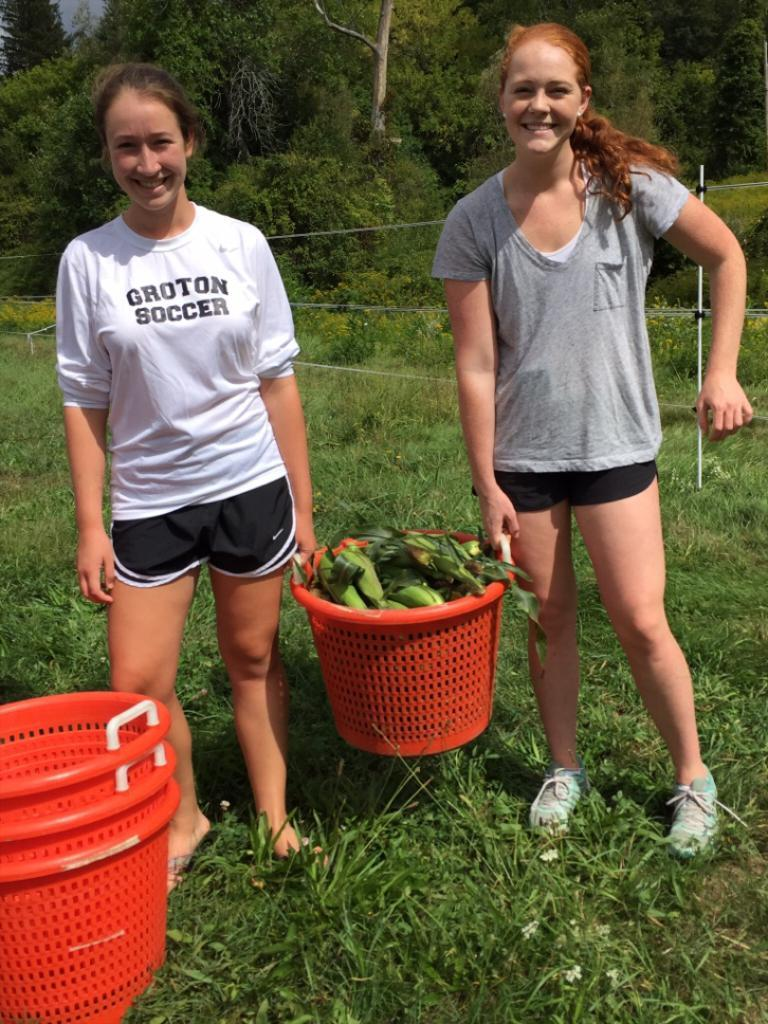Provide a one-sentence caption for the provided image. A woman wearing a Groton Soccer shirt holds a basket full of corn alongside another woman. 